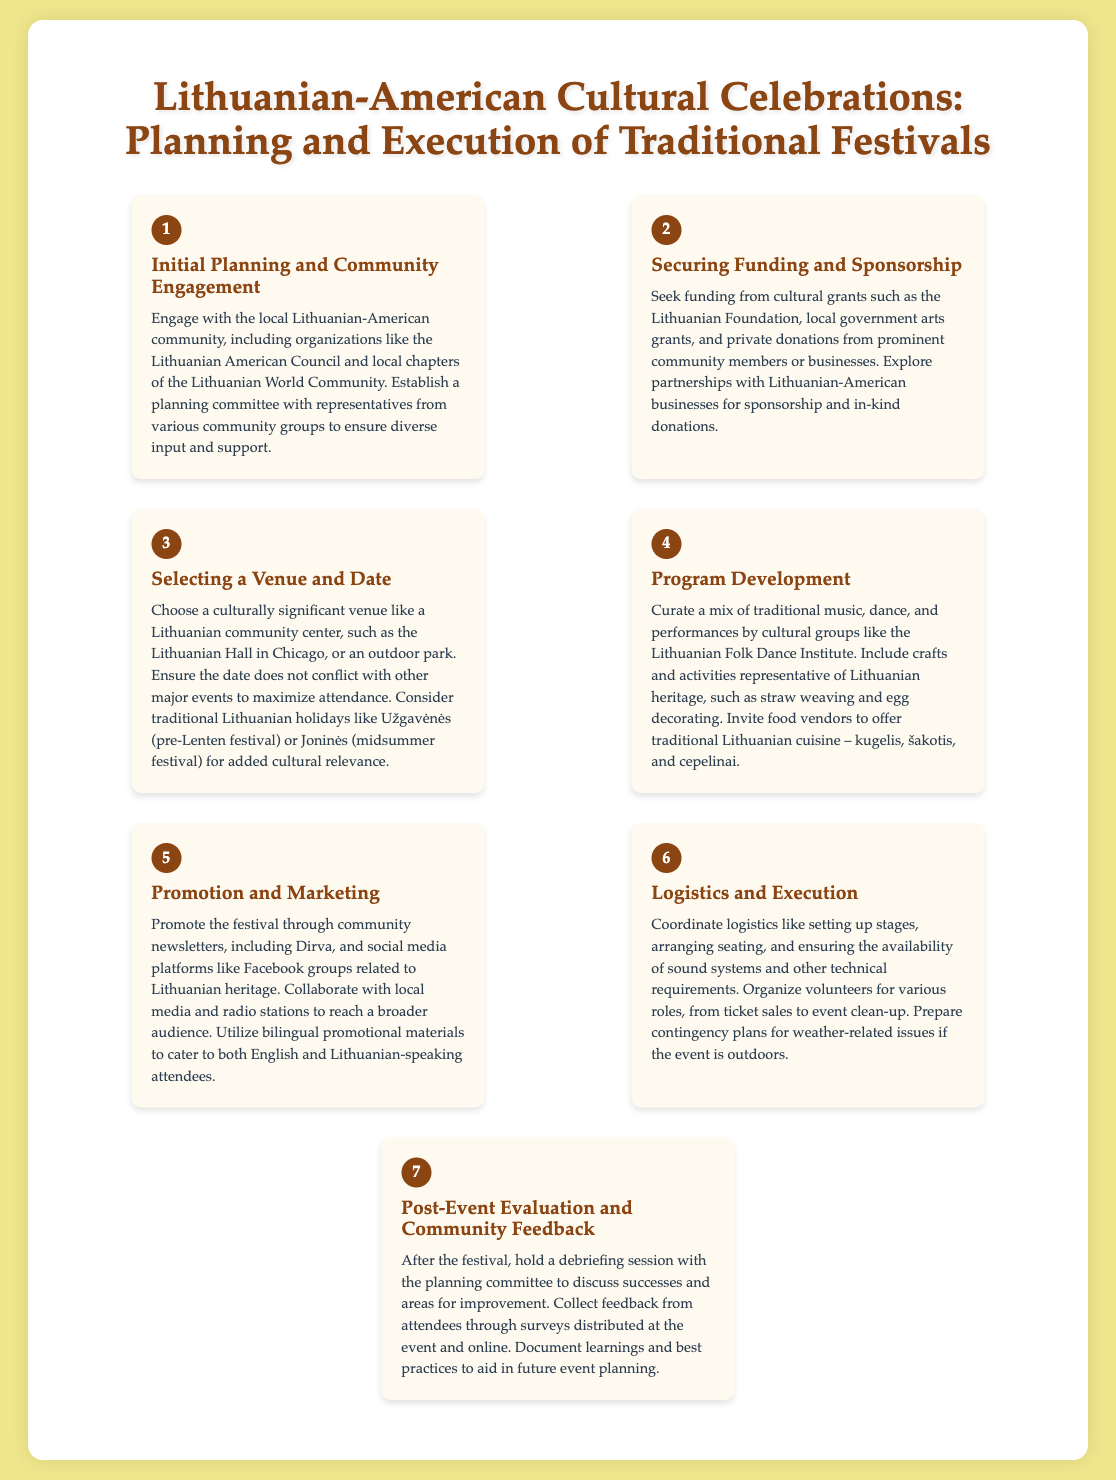what is the first step in planning a Lithuanian-American festival? The first step is to engage with the local Lithuanian-American community and establish a planning committee.
Answer: Initial Planning and Community Engagement which organization is mentioned for securing funding? The organization mentioned is the Lithuanian Foundation.
Answer: Lithuanian Foundation how many steps are outlined in the infographic? The infographic outlines a total of seven steps in the process.
Answer: 7 what is a preferred venue for hosting the festival? A culturally significant venue like a Lithuanian community center is preferred.
Answer: Lithuanian community center which traditional dish is mentioned as a food offering? The traditional dish mentioned is kugelis.
Answer: kugelis what type of materials should be used for promotions? Bilingual promotional materials should be used.
Answer: Bilingual promotional materials what is a key aspect of the program development step? A key aspect is to include traditional music and dance performances.
Answer: Traditional music and dance performances when should feedback be collected after the event? Feedback should be collected after the festival during a debriefing session.
Answer: After the festival during a debriefing session 